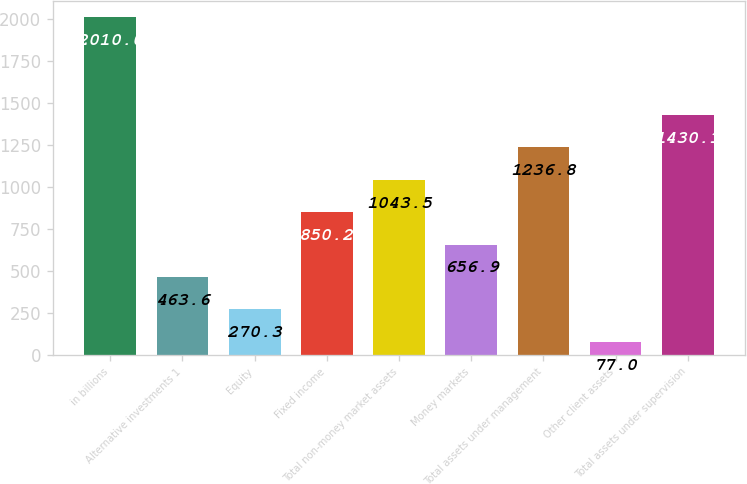Convert chart to OTSL. <chart><loc_0><loc_0><loc_500><loc_500><bar_chart><fcel>in billions<fcel>Alternative investments 1<fcel>Equity<fcel>Fixed income<fcel>Total non-money market assets<fcel>Money markets<fcel>Total assets under management<fcel>Other client assets<fcel>Total assets under supervision<nl><fcel>2010<fcel>463.6<fcel>270.3<fcel>850.2<fcel>1043.5<fcel>656.9<fcel>1236.8<fcel>77<fcel>1430.1<nl></chart> 